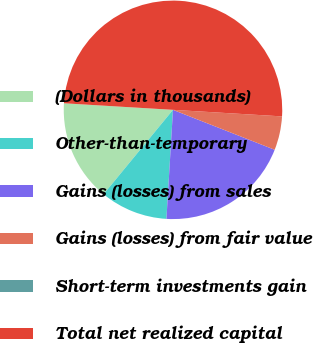Convert chart. <chart><loc_0><loc_0><loc_500><loc_500><pie_chart><fcel>(Dollars in thousands)<fcel>Other-than-temporary<fcel>Gains (losses) from sales<fcel>Gains (losses) from fair value<fcel>Short-term investments gain<fcel>Total net realized capital<nl><fcel>15.0%<fcel>10.0%<fcel>20.0%<fcel>5.0%<fcel>0.0%<fcel>50.0%<nl></chart> 